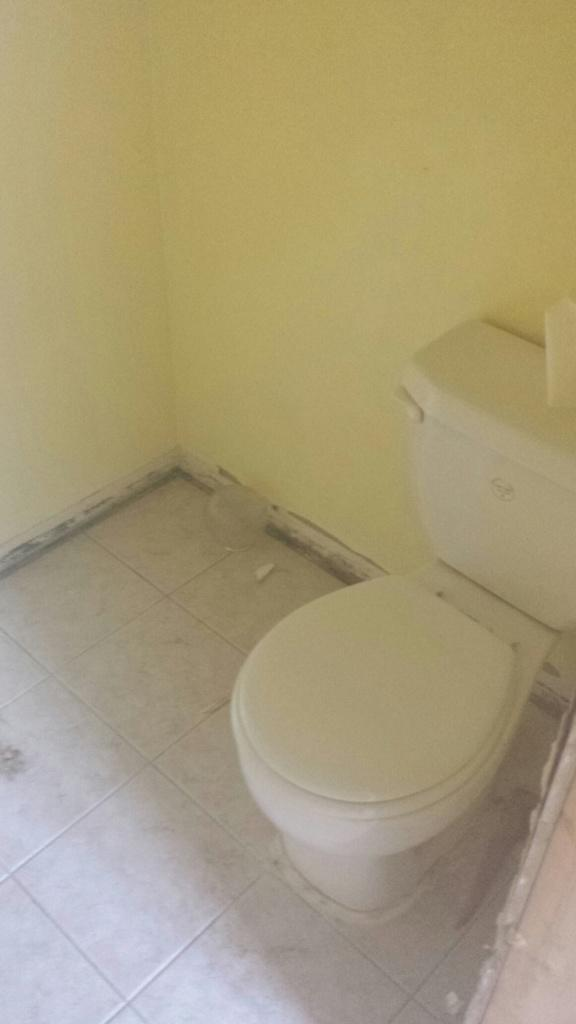What is the main object on the floor in the image? There is a toilet with the flush on the floor. What can be seen in the background of the image? There is a wall visible in the image. Where is the light switch located in the image? There is no light switch visible in the image. Can you see any family members in the image? There is no indication of any family members present in the image. 